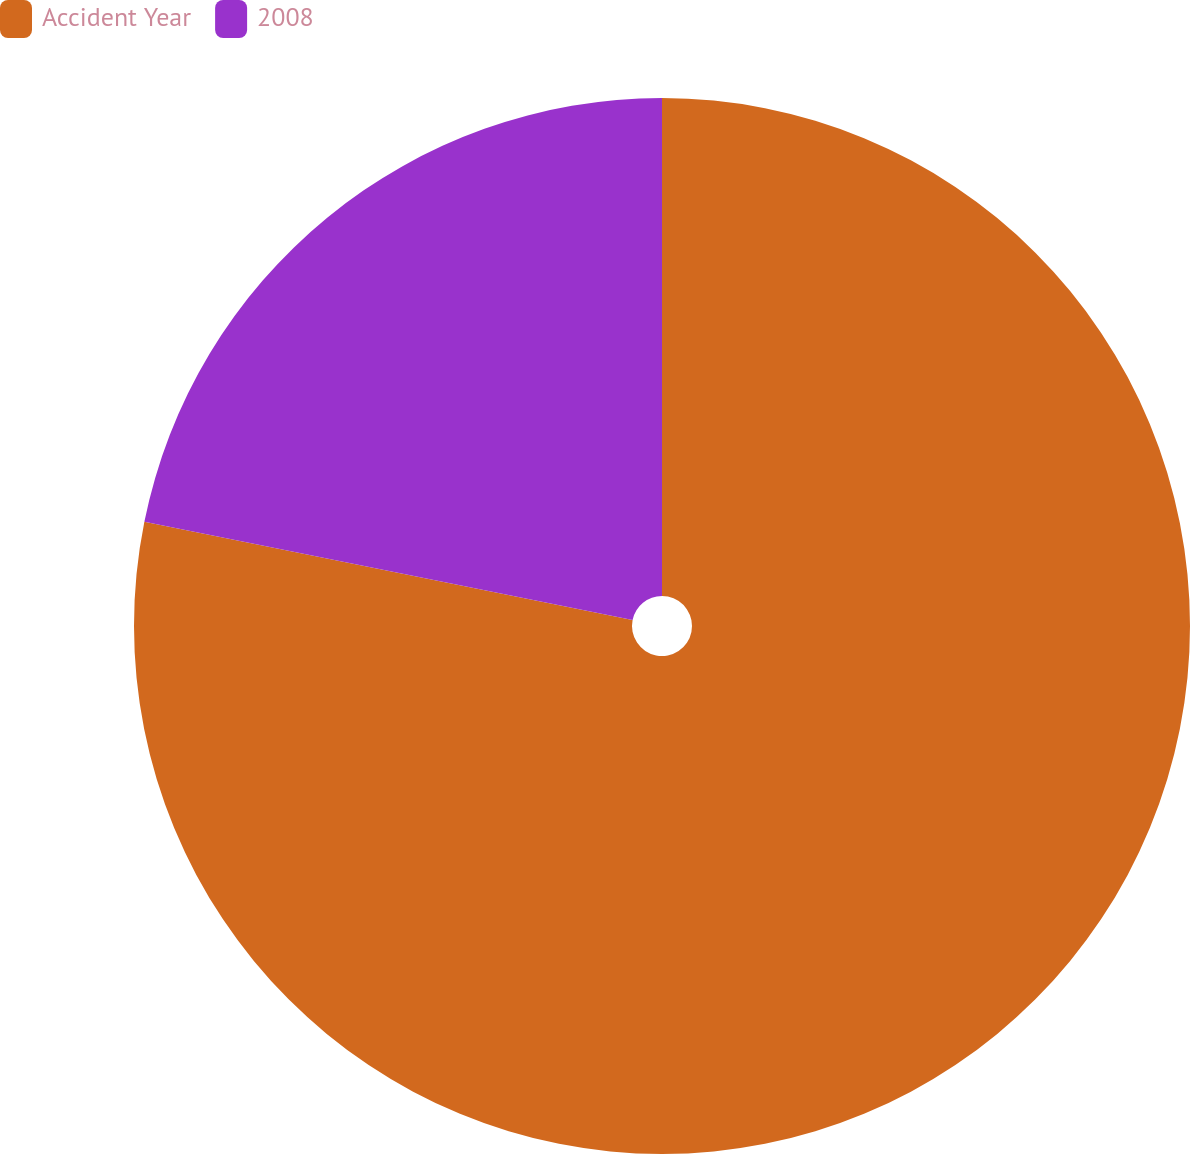Convert chart. <chart><loc_0><loc_0><loc_500><loc_500><pie_chart><fcel>Accident Year<fcel>2008<nl><fcel>78.16%<fcel>21.84%<nl></chart> 